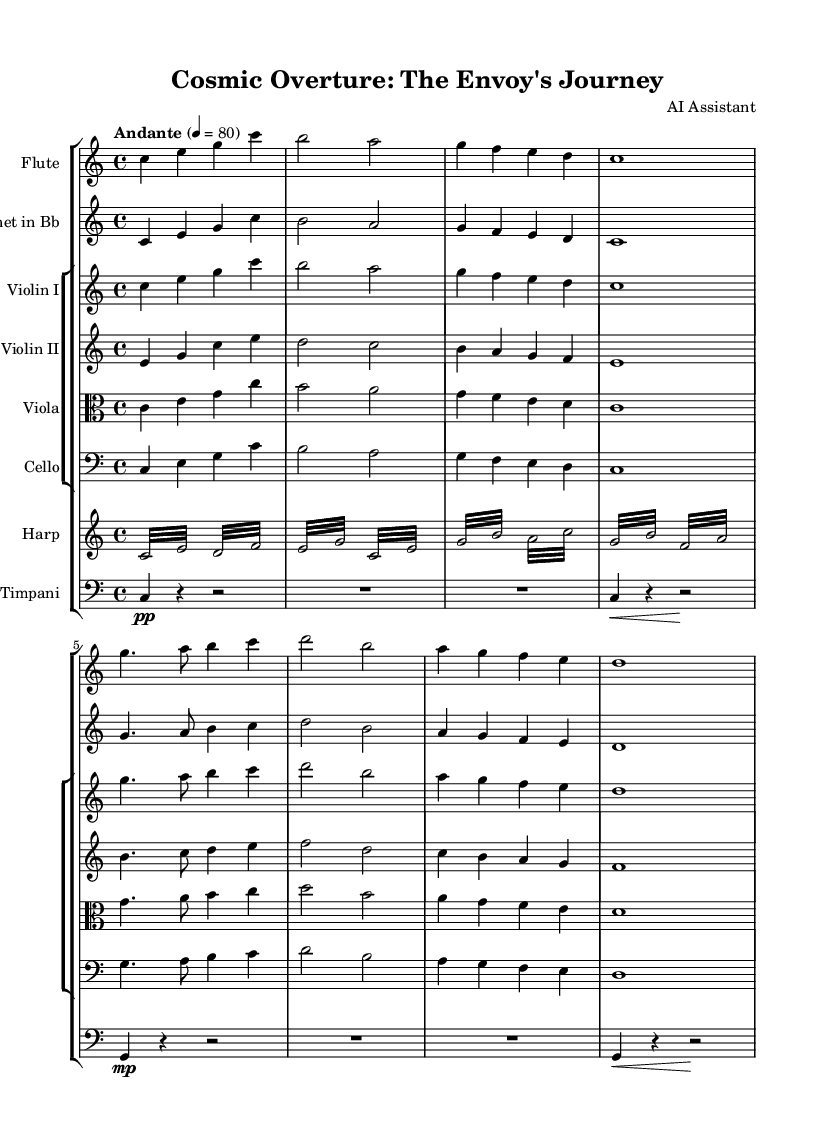What is the key signature of this music? The key signature shows no sharps or flats, indicating that it is in C major.
Answer: C major What is the time signature of the piece? The time signature is indicated as 4/4, meaning there are four beats per measure.
Answer: 4/4 What is the tempo marking used in this composition? The tempo marking is "Andante," which typically suggests a moderately slow tempo.
Answer: Andante How many instruments are featured in this composition? Counting the staves in the score, there are six distinct instruments represented: Flute, Clarinet, two Violins, Viola, Cello, Harp, and Timpani.
Answer: Seven What type of musical form is primarily followed in the piece? The piece follows a repeating melodic structure, indicating a theme and variations design typical in classical music, though it isn't strictly defined.
Answer: Theme and variations What is the highest pitch instrument in this score? The Flute is the highest in pitch among all instruments, playing in a register that extends generally above the strings and the rest.
Answer: Flute What technique is predominantly used in the harp part? The harp part consists of tremolos, which are rapid repetitions of the same note, increasing the ethereal quality suitable for cosmic themes.
Answer: Tremolo 